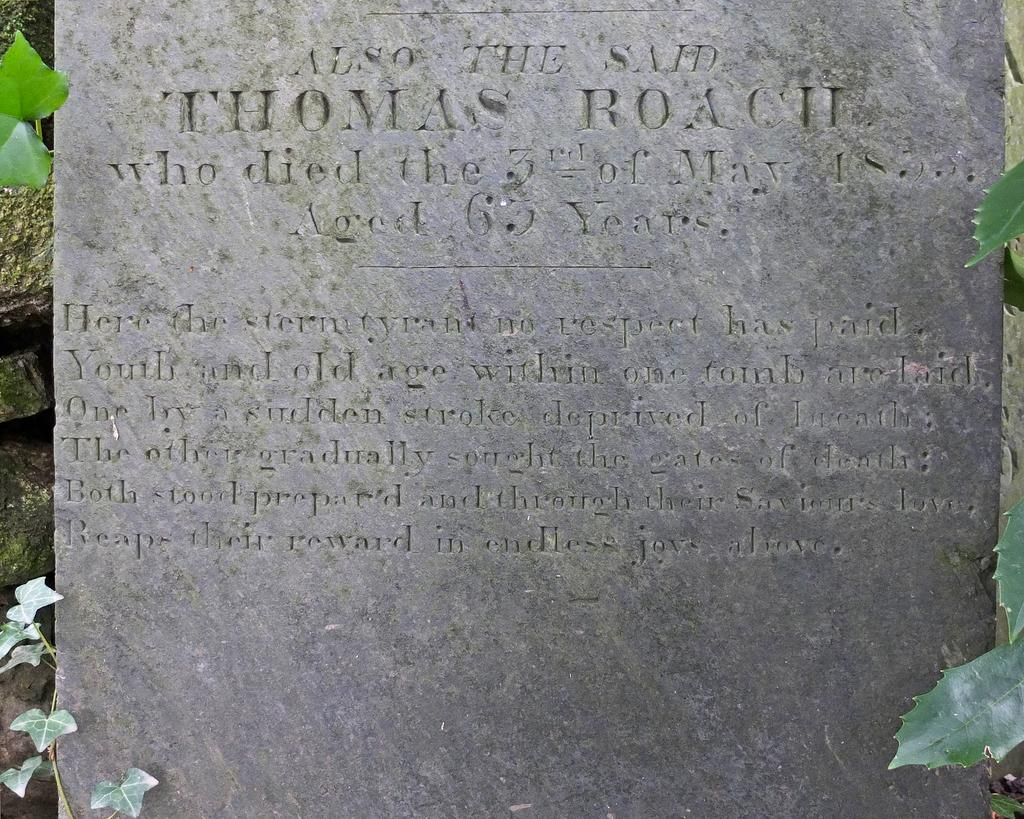What is written on in the image? There is writing on a rock wall in the image. What type of vegetation can be seen in the image? Green leaves are visible in the image. What type of train can be seen passing by in the image? There is no train present in the image. What type of bomb is visible in the image? There is no bomb present in the image. What type of lamp is illuminating the area in the image? There is no lamp present in the image. 